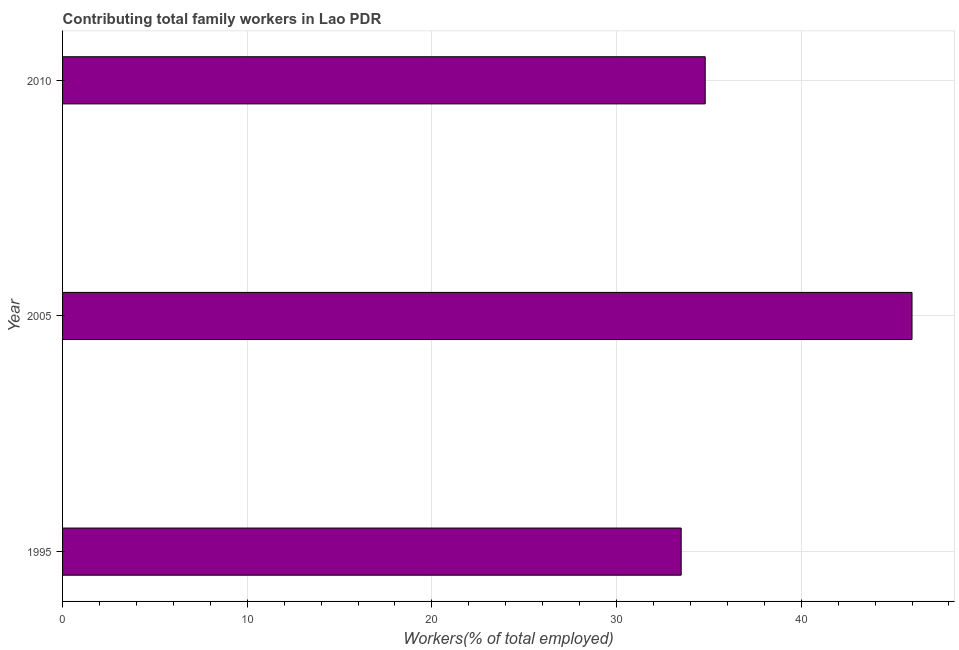Does the graph contain any zero values?
Make the answer very short. No. What is the title of the graph?
Make the answer very short. Contributing total family workers in Lao PDR. What is the label or title of the X-axis?
Your answer should be compact. Workers(% of total employed). What is the label or title of the Y-axis?
Keep it short and to the point. Year. What is the contributing family workers in 1995?
Provide a short and direct response. 33.5. Across all years, what is the maximum contributing family workers?
Your answer should be very brief. 46. Across all years, what is the minimum contributing family workers?
Your answer should be very brief. 33.5. In which year was the contributing family workers maximum?
Your answer should be compact. 2005. In which year was the contributing family workers minimum?
Offer a very short reply. 1995. What is the sum of the contributing family workers?
Your answer should be very brief. 114.3. What is the average contributing family workers per year?
Your answer should be compact. 38.1. What is the median contributing family workers?
Give a very brief answer. 34.8. In how many years, is the contributing family workers greater than 6 %?
Provide a short and direct response. 3. Do a majority of the years between 2010 and 2005 (inclusive) have contributing family workers greater than 2 %?
Give a very brief answer. No. What is the ratio of the contributing family workers in 2005 to that in 2010?
Your response must be concise. 1.32. Is the contributing family workers in 1995 less than that in 2010?
Your answer should be very brief. Yes. Is the difference between the contributing family workers in 1995 and 2010 greater than the difference between any two years?
Keep it short and to the point. No. What is the difference between the highest and the lowest contributing family workers?
Offer a terse response. 12.5. How many bars are there?
Keep it short and to the point. 3. Are all the bars in the graph horizontal?
Offer a terse response. Yes. Are the values on the major ticks of X-axis written in scientific E-notation?
Provide a short and direct response. No. What is the Workers(% of total employed) in 1995?
Provide a short and direct response. 33.5. What is the Workers(% of total employed) in 2010?
Provide a short and direct response. 34.8. What is the difference between the Workers(% of total employed) in 1995 and 2010?
Keep it short and to the point. -1.3. What is the difference between the Workers(% of total employed) in 2005 and 2010?
Give a very brief answer. 11.2. What is the ratio of the Workers(% of total employed) in 1995 to that in 2005?
Provide a succinct answer. 0.73. What is the ratio of the Workers(% of total employed) in 1995 to that in 2010?
Your response must be concise. 0.96. What is the ratio of the Workers(% of total employed) in 2005 to that in 2010?
Give a very brief answer. 1.32. 